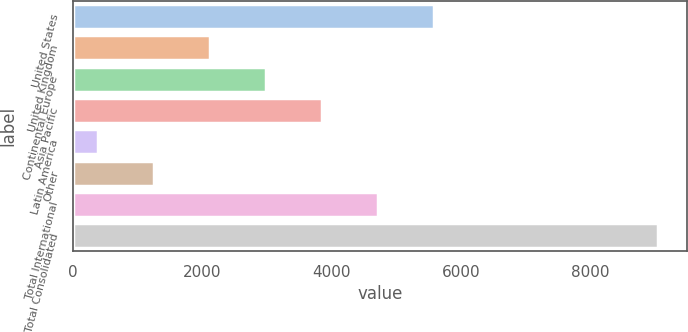Convert chart to OTSL. <chart><loc_0><loc_0><loc_500><loc_500><bar_chart><fcel>United States<fcel>United Kingdom<fcel>Continental Europe<fcel>Asia Pacific<fcel>Latin America<fcel>Other<fcel>Total International<fcel>Total Consolidated<nl><fcel>5583.2<fcel>2118.8<fcel>2984.9<fcel>3851<fcel>386.6<fcel>1252.7<fcel>4717.1<fcel>9047.6<nl></chart> 